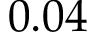Convert formula to latex. <formula><loc_0><loc_0><loc_500><loc_500>0 . 0 4</formula> 